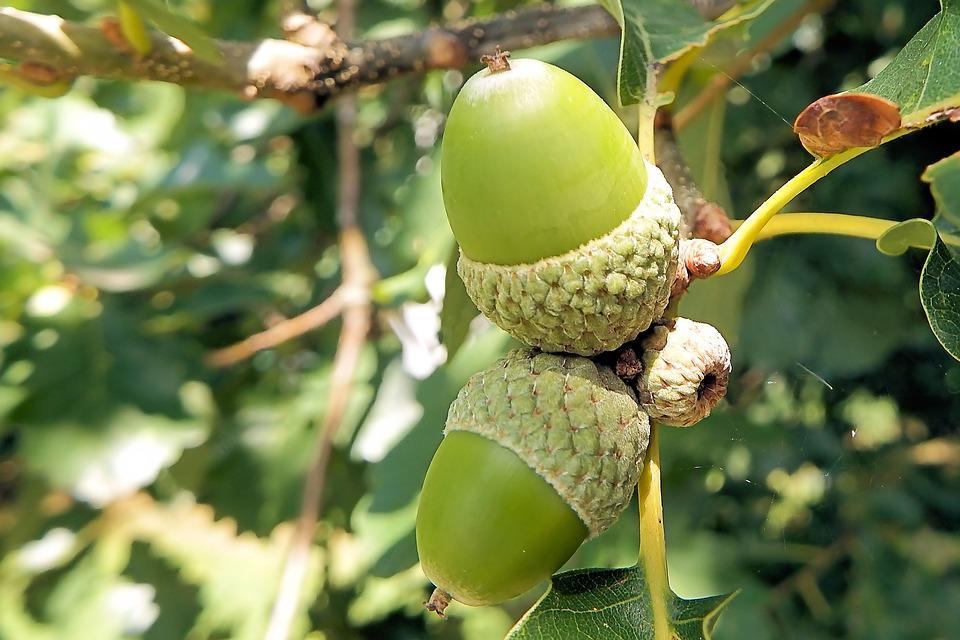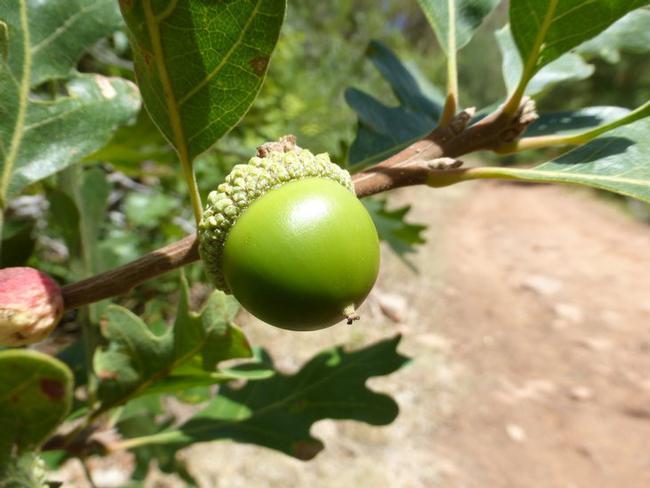The first image is the image on the left, the second image is the image on the right. Given the left and right images, does the statement "There are more than five acorns." hold true? Answer yes or no. No. The first image is the image on the left, the second image is the image on the right. Given the left and right images, does the statement "The combined images contain no more than five acorns, and all acorns pictured have the same basic shape." hold true? Answer yes or no. Yes. 